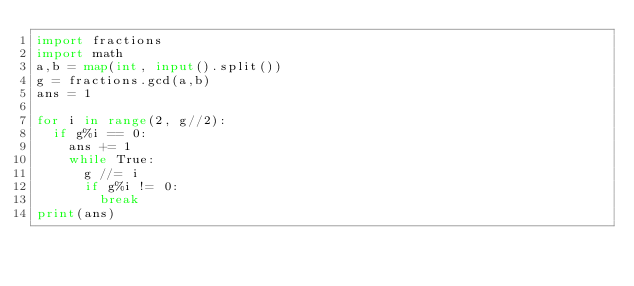Convert code to text. <code><loc_0><loc_0><loc_500><loc_500><_Python_>import fractions
import math
a,b = map(int, input().split())
g = fractions.gcd(a,b)
ans = 1

for i in range(2, g//2):
  if g%i == 0:
    ans += 1
    while True:
      g //= i
      if g%i != 0:
        break
print(ans)</code> 